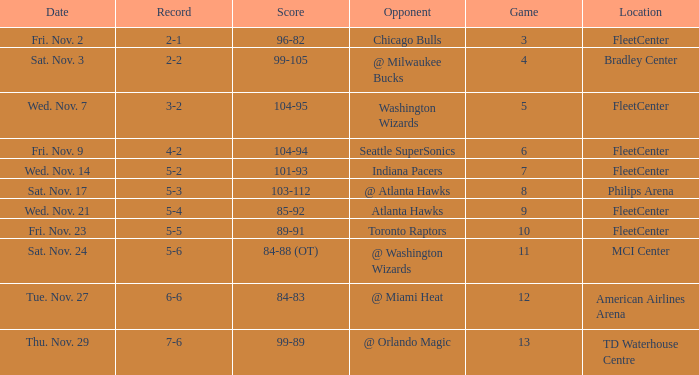On what date did Fleetcenter have a game lower than 9 with a score of 104-94? Fri. Nov. 9. 